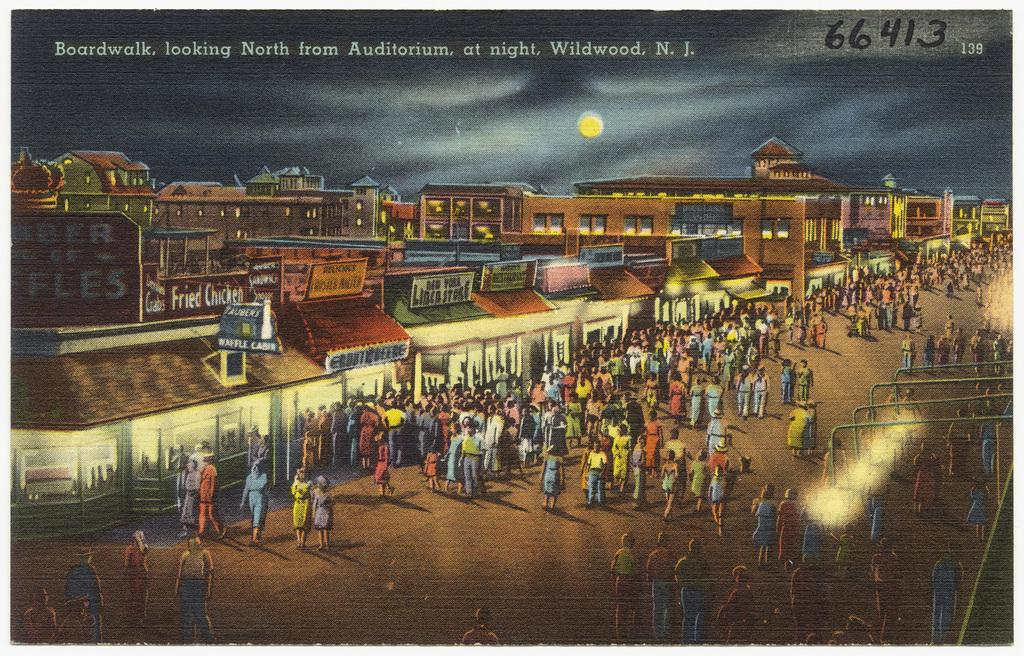<image>
Relay a brief, clear account of the picture shown. A postcard showing the boardwalk in New Jersey, numbered 664113. 